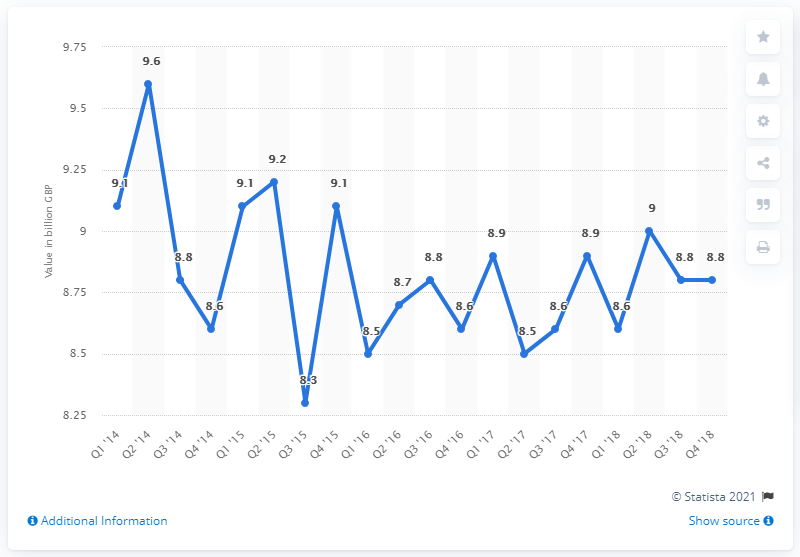Mention a couple of crucial points in this snapshot. The total premiums of general insurance companies in the fourth quarter of 2018 were 8.8. In the second quarter of 2014, the largest amount of premiums was 9.6 million. 